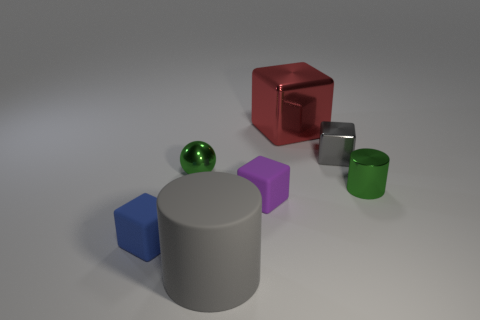Are there any other things that have the same size as the red block?
Your answer should be very brief. Yes. How many small green things are left of the small green cylinder?
Make the answer very short. 1. Are there the same number of purple things that are left of the purple cube and large brown things?
Make the answer very short. Yes. How many things are either small blue objects or purple cubes?
Give a very brief answer. 2. Are there any other things that have the same shape as the purple thing?
Provide a succinct answer. Yes. What shape is the small metal thing that is in front of the tiny green shiny object that is left of the small gray object?
Keep it short and to the point. Cylinder. What is the shape of the big gray thing that is the same material as the purple block?
Ensure brevity in your answer.  Cylinder. There is a cylinder on the left side of the tiny green metallic object that is in front of the shiny sphere; what is its size?
Give a very brief answer. Large. The blue thing is what shape?
Give a very brief answer. Cube. How many tiny objects are either metal balls or brown cylinders?
Provide a succinct answer. 1. 